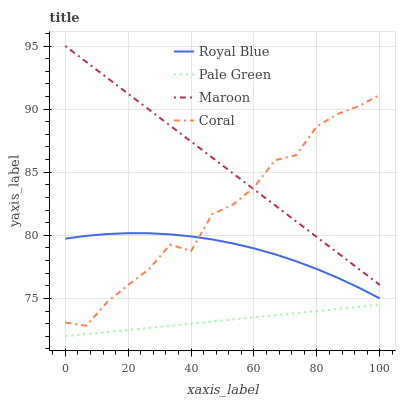Does Pale Green have the minimum area under the curve?
Answer yes or no. Yes. Does Maroon have the maximum area under the curve?
Answer yes or no. Yes. Does Coral have the minimum area under the curve?
Answer yes or no. No. Does Coral have the maximum area under the curve?
Answer yes or no. No. Is Maroon the smoothest?
Answer yes or no. Yes. Is Coral the roughest?
Answer yes or no. Yes. Is Pale Green the smoothest?
Answer yes or no. No. Is Pale Green the roughest?
Answer yes or no. No. Does Pale Green have the lowest value?
Answer yes or no. Yes. Does Coral have the lowest value?
Answer yes or no. No. Does Maroon have the highest value?
Answer yes or no. Yes. Does Coral have the highest value?
Answer yes or no. No. Is Pale Green less than Maroon?
Answer yes or no. Yes. Is Maroon greater than Royal Blue?
Answer yes or no. Yes. Does Coral intersect Royal Blue?
Answer yes or no. Yes. Is Coral less than Royal Blue?
Answer yes or no. No. Is Coral greater than Royal Blue?
Answer yes or no. No. Does Pale Green intersect Maroon?
Answer yes or no. No. 